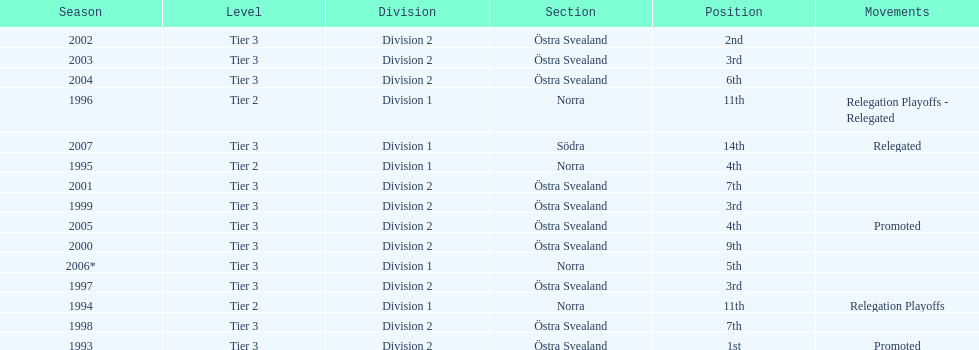In 2000 they finished 9th in their division, did they perform better or worse the next season? Better. 